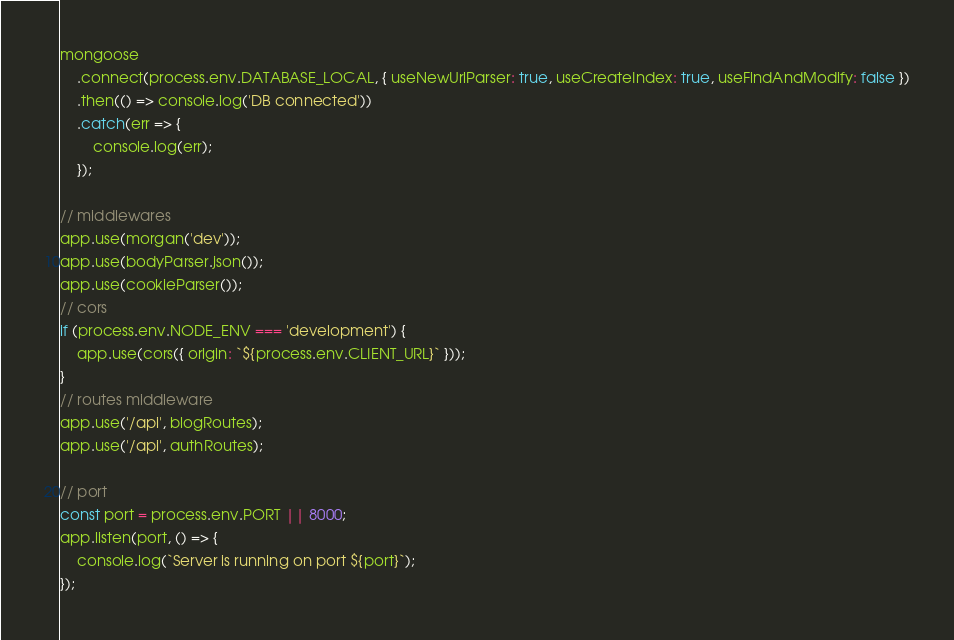<code> <loc_0><loc_0><loc_500><loc_500><_JavaScript_>mongoose
    .connect(process.env.DATABASE_LOCAL, { useNewUrlParser: true, useCreateIndex: true, useFindAndModify: false })
    .then(() => console.log('DB connected'))
    .catch(err => {
        console.log(err);
    });

// middlewares
app.use(morgan('dev'));
app.use(bodyParser.json());
app.use(cookieParser());
// cors
if (process.env.NODE_ENV === 'development') {
    app.use(cors({ origin: `${process.env.CLIENT_URL}` }));
}
// routes middleware
app.use('/api', blogRoutes);
app.use('/api', authRoutes);

// port
const port = process.env.PORT || 8000;
app.listen(port, () => {
    console.log(`Server is running on port ${port}`);
});
</code> 